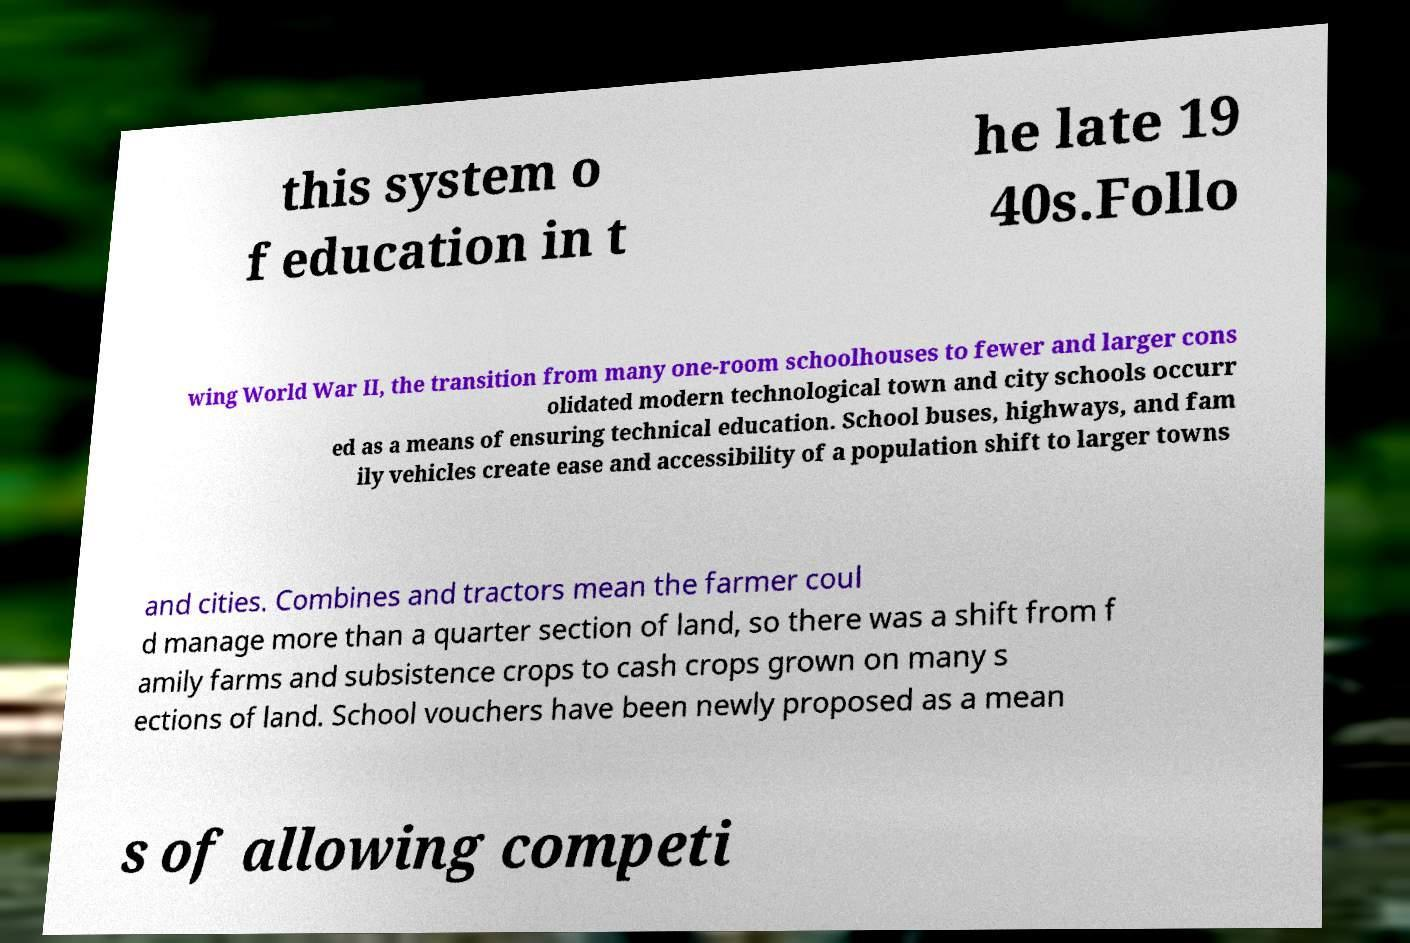Please read and relay the text visible in this image. What does it say? this system o f education in t he late 19 40s.Follo wing World War II, the transition from many one-room schoolhouses to fewer and larger cons olidated modern technological town and city schools occurr ed as a means of ensuring technical education. School buses, highways, and fam ily vehicles create ease and accessibility of a population shift to larger towns and cities. Combines and tractors mean the farmer coul d manage more than a quarter section of land, so there was a shift from f amily farms and subsistence crops to cash crops grown on many s ections of land. School vouchers have been newly proposed as a mean s of allowing competi 